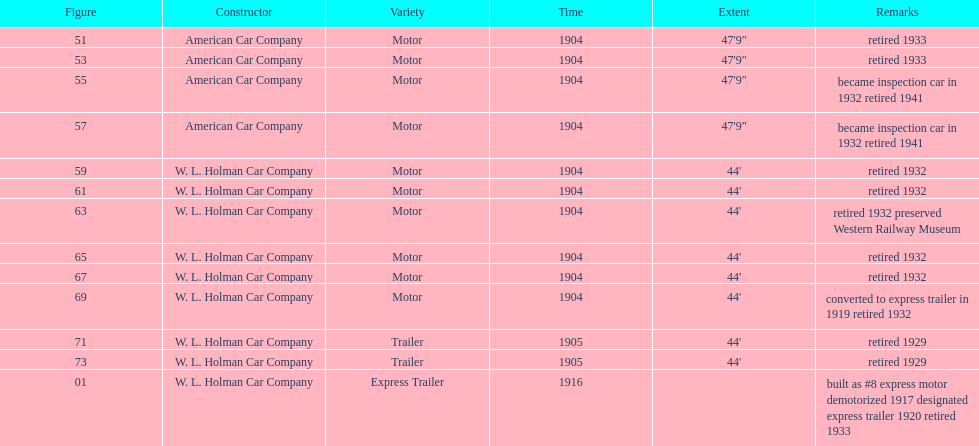What was the total number of cars listed? 13. 